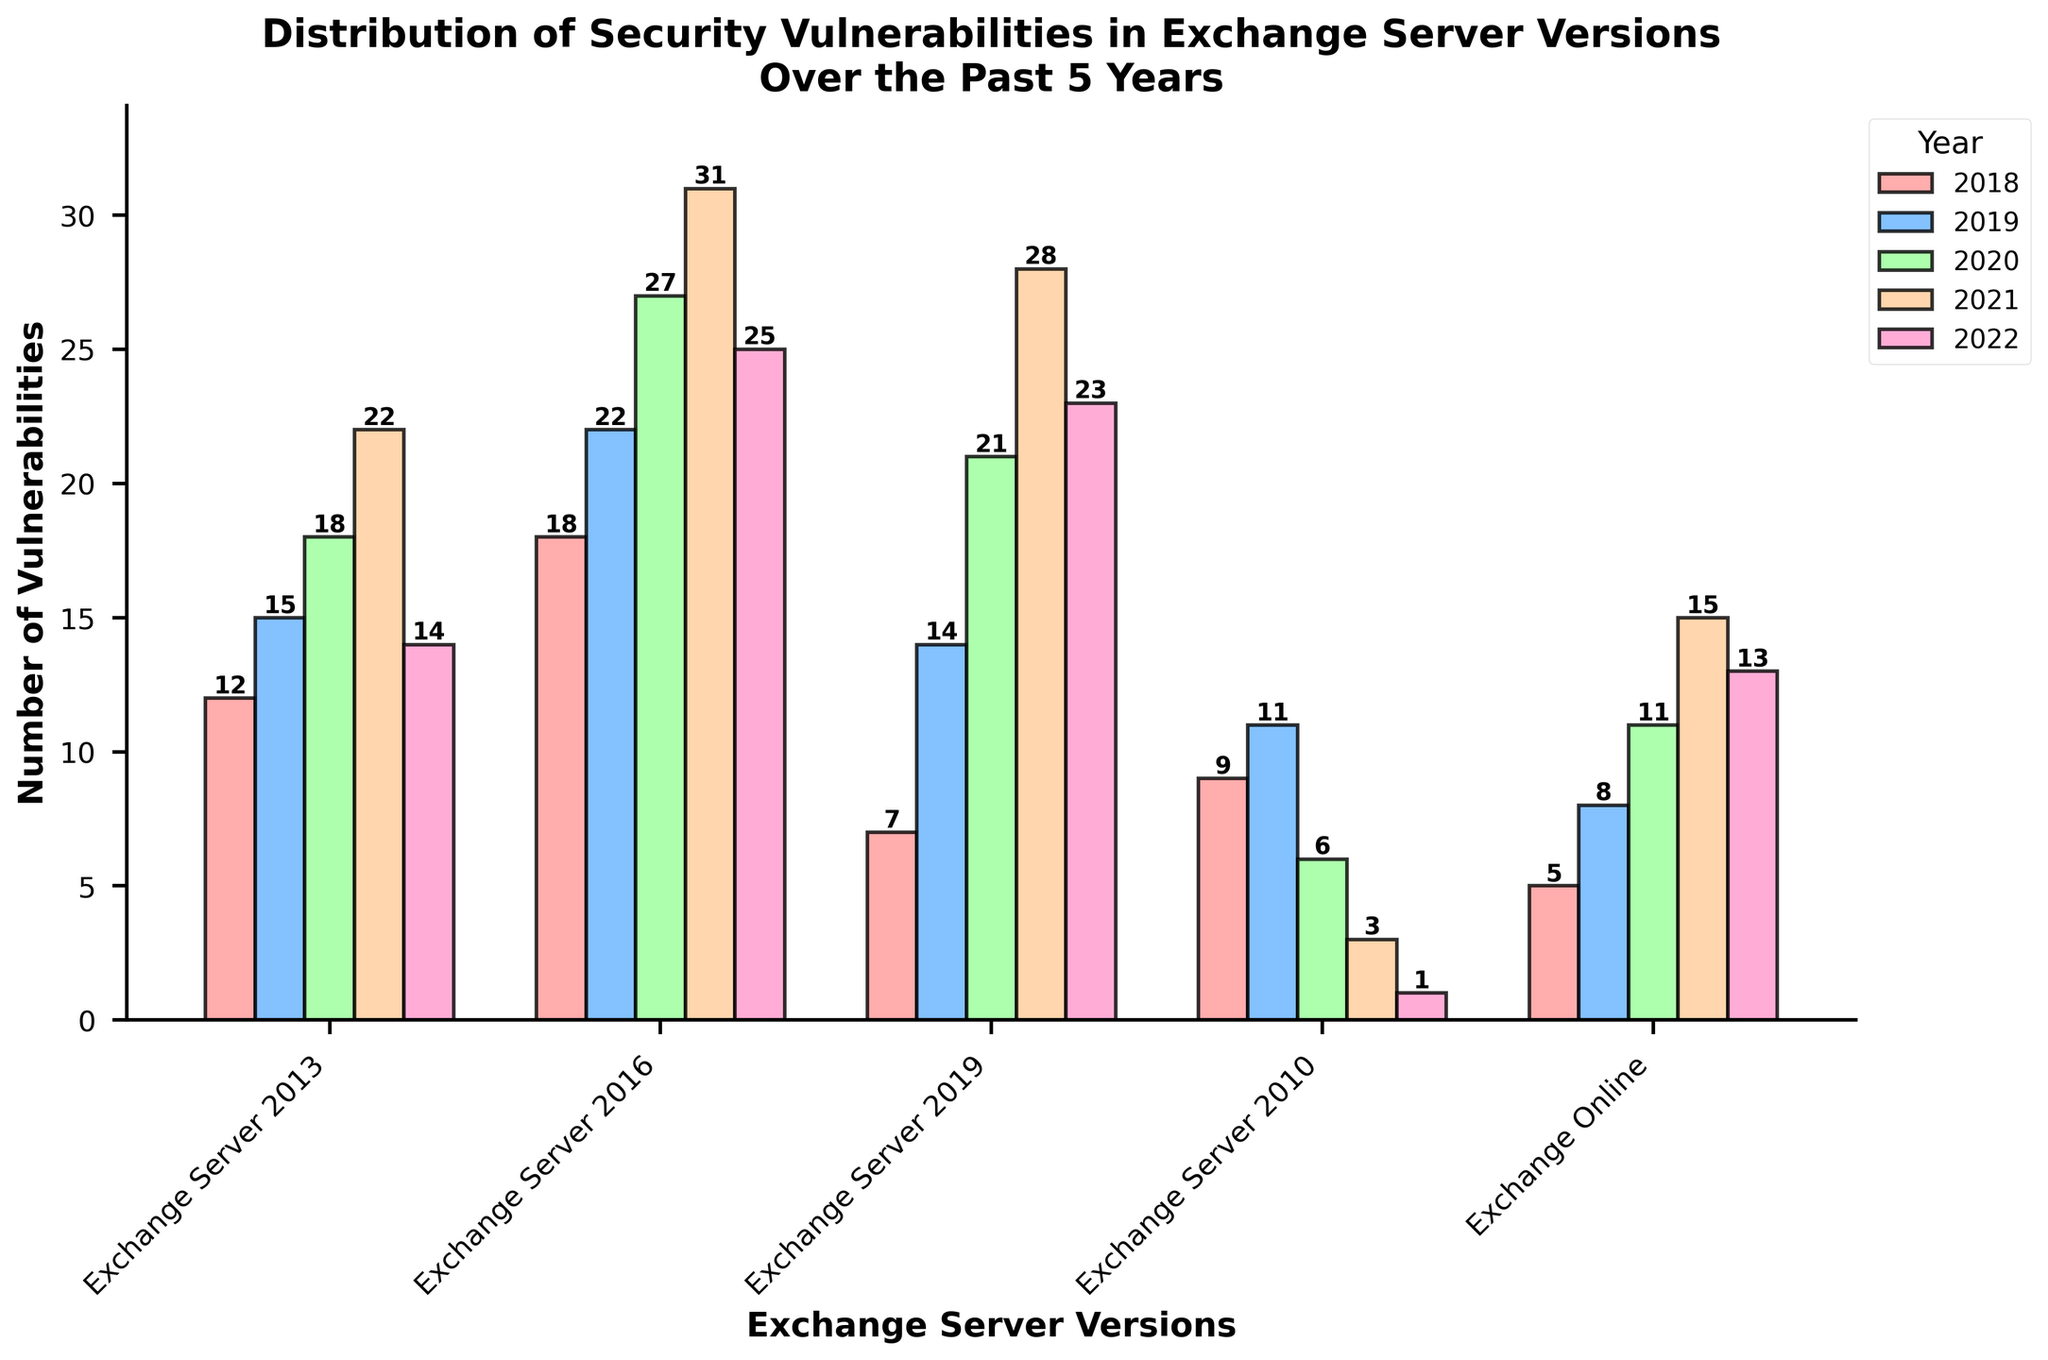What is the total number of vulnerabilities reported for Exchange Server 2016 in 2020 and 2021 combined? To find the total number of vulnerabilities in 2020 and 2021 for Exchange Server 2016, look at the bars for these years and sum the values shown: 27 (2020) + 31 (2021) = 58
Answer: 58 Which Exchange Server version has the highest number of vulnerabilities in 2021? To determine which version has the highest vulnerabilities in 2021, compare the heights of all the bars for 2021. Exchange Server 2016 has the highest bar with 31 vulnerabilities in that year by visually inspecting the chart.
Answer: Exchange Server 2016 How many more vulnerabilities did Exchange Server 2019 have in 2022 compared to Exchange Server 2010? To find how many more vulnerabilities Exchange Server 2019 had than Exchange Server 2010 in 2022, look at the chart values: Exchange Server 2019 had 23, and Exchange Server 2010 had 1. Subtract the smaller value from the larger one: 23 - 1 = 22
Answer: 22 What is the average number of vulnerabilities for Exchange Online over the past 5 years? To calculate the average, add the number of vulnerabilities for each year and divide by the number of years. Sum the values: 5 (2018) + 8 (2019) + 11 (2020) + 15 (2021) + 13 (2022) = 52. Then divide by 5: 52 / 5 = 10.4
Answer: 10.4 In which year did Exchange Server 2013 have the most vulnerabilities reported, and how many were reported that year? To determine the year with the most vulnerabilities reported for Exchange Server 2013, compare the heights of the bars across the years. The tallest bar is for 2021, where 22 vulnerabilities were reported, based on the chart.
Answer: 2021, 22 By how much did the number of vulnerabilities for Exchange Server 2010 decrease from 2018 to 2022? To find the decrease, subtract the number of vulnerabilities in 2022 from 2018 for Exchange Server 2010. Values are 9 (2018) and 1 (2022). Subtract: 9 - 1 = 8
Answer: 8 Which year's vulnerabilities are shown with the red bars in the chart, and which version has the lowest number in that year? The red bars represent the vulnerabilities for 2018. By examining the heights of the red bars, Exchange Online has the lowest number of vulnerabilities in 2018 with 5, as seen in the chart.
Answer: 2018, Exchange Online What is the trend of security vulnerabilities for Exchange Server 2019 from 2018 to 2022? To describe the trend for Exchange Server 2019, observe the bars' height from 2018 to 2022. The number of vulnerabilities increases from 7 in 2018 to a peak of 28 in 2021, then slightly decreases to 23 in 2022.
Answer: Increase until 2021, then decrease 